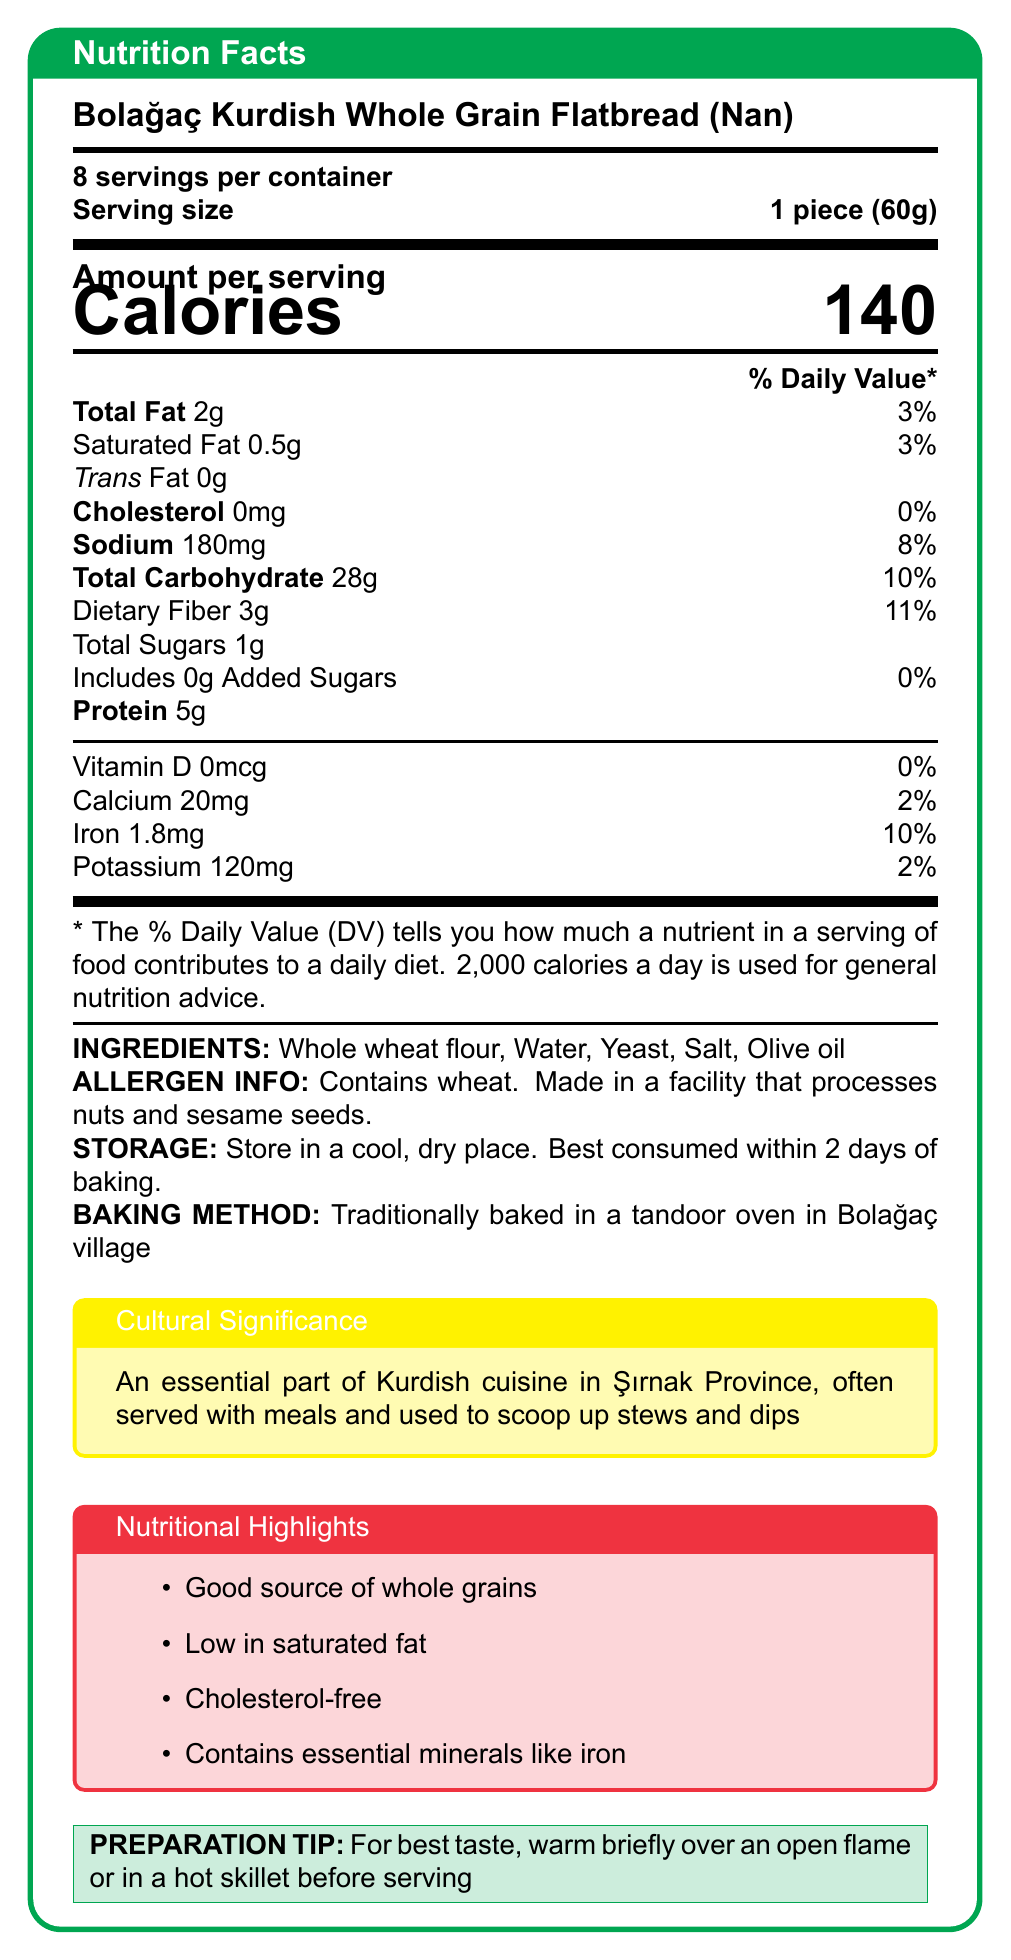what is the serving size? The document states that the serving size is 1 piece weighing 60 grams.
Answer: 1 piece (60g) how many servings are in the container? The document mentions there are 8 servings per container.
Answer: 8 how many calories are in one serving? The document specifies that each serving contains 140 calories.
Answer: 140 what is the total fat content per serving? The total fat content per serving is listed as 2 grams.
Answer: 2g how much dietary fiber is in one serving? The dietary fiber content per serving is indicated as 3 grams, which is 11% of the daily value.
Answer: 3g which ingredient is not listed in the ingredients section? A. Whole wheat flour B. Salt C. Sugar D. Yeast The ingredients listed are Whole wheat flour, Water, Yeast, Salt, and Olive oil. Sugar is not mentioned.
Answer: C what percentage of the daily value of sodium does one serving contain? A. 2% B. 8% C. 10% D. 15% The document states that the sodium content per serving is 180mg, which is 8% of the daily value.
Answer: B does this flatbread contain cholesterol? Yes/No The document specifies that the flatbread contains 0mg of cholesterol, indicating that it is cholesterol-free.
Answer: No summarize the main idea of this document. The document includes the product name, serving size, number of servings, nutritional facts such as calorie count, fat content, and amounts of various nutrients, ingredient list, allergen information, storage instructions, baking method, cultural significance, nutritional highlights, and preparation tips.
Answer: The document provides nutritional information, ingredients, and other relevant details for Bolağaç Kurdish Whole Grain Flatbread (Nan), highlighting its whole grain ingredients, low saturated fat content, and cultural significance in Kurdish cuisine. what are the storage instructions for this flatbread? The document advises storing the flatbread in a cool, dry place and consuming it within 2 days of baking.
Answer: Store in a cool, dry place. Best consumed within 2 days of baking. what vitamins and minerals are present in the flatbread, and what are their daily values? The document specifies the amounts and daily values of Vitamin D, Calcium, Iron, and Potassium in the flatbread.
Answer: Vitamin D (0mcg, 0%), Calcium (20mg, 2%), Iron (1.8mg, 10%), Potassium (120mg, 2%) describe the traditional method of baking this flatbread mentioned in the document. According to the document, the flatbread is traditionally baked in a tandoor oven in Bolağaç village.
Answer: Traditionally baked in a tandoor oven in Bolağaç village is this flatbread recommended for those avoiding high cholesterol foods? Why/Why not? The document states that the flatbread is cholesterol-free, making it suitable for those avoiding high cholesterol foods.
Answer: Yes, it is recommended because it contains 0mg of cholesterol. what minerals does the flatbread provide a good source of? The document highlights that the flatbread contains essential minerals like iron and provides 10% of the daily value for iron per serving.
Answer: Iron does the flatbread contain any added sugars? The document states that the flatbread contains 0g of added sugars.
Answer: No can this flatbread be considered a good source of protein? The flatbread contains 5g of protein per serving. While this contributes to protein intake, it is not enough to be considered a high-protein food.
Answer: Not really what percentage of the daily fiber requirement does one serving fulfill? The document states that one serving provides 3g of dietary fiber, which is 11% of the daily value.
Answer: 11% is this flatbread suitable for individuals with nut allergies? The document states that the flatbread is made in a facility that processes nuts and sesame seeds, which may pose a risk to individuals with nut allergies. However, it does not provide enough information to confirm safety.
Answer: Cannot be determined what preparation tip is given for the best taste? The document provides a preparation tip to warm the flatbread briefly over an open flame or in a hot skillet for the best taste.
Answer: Warm briefly over an open flame or in a hot skillet before serving. 